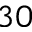<formula> <loc_0><loc_0><loc_500><loc_500>^ { 3 0 }</formula> 